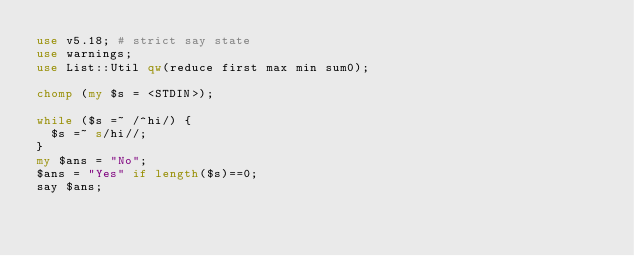<code> <loc_0><loc_0><loc_500><loc_500><_Perl_>use v5.18; # strict say state
use warnings;
use List::Util qw(reduce first max min sum0);

chomp (my $s = <STDIN>);

while ($s =~ /^hi/) {
  $s =~ s/hi//;
}
my $ans = "No";
$ans = "Yes" if length($s)==0;
say $ans;</code> 